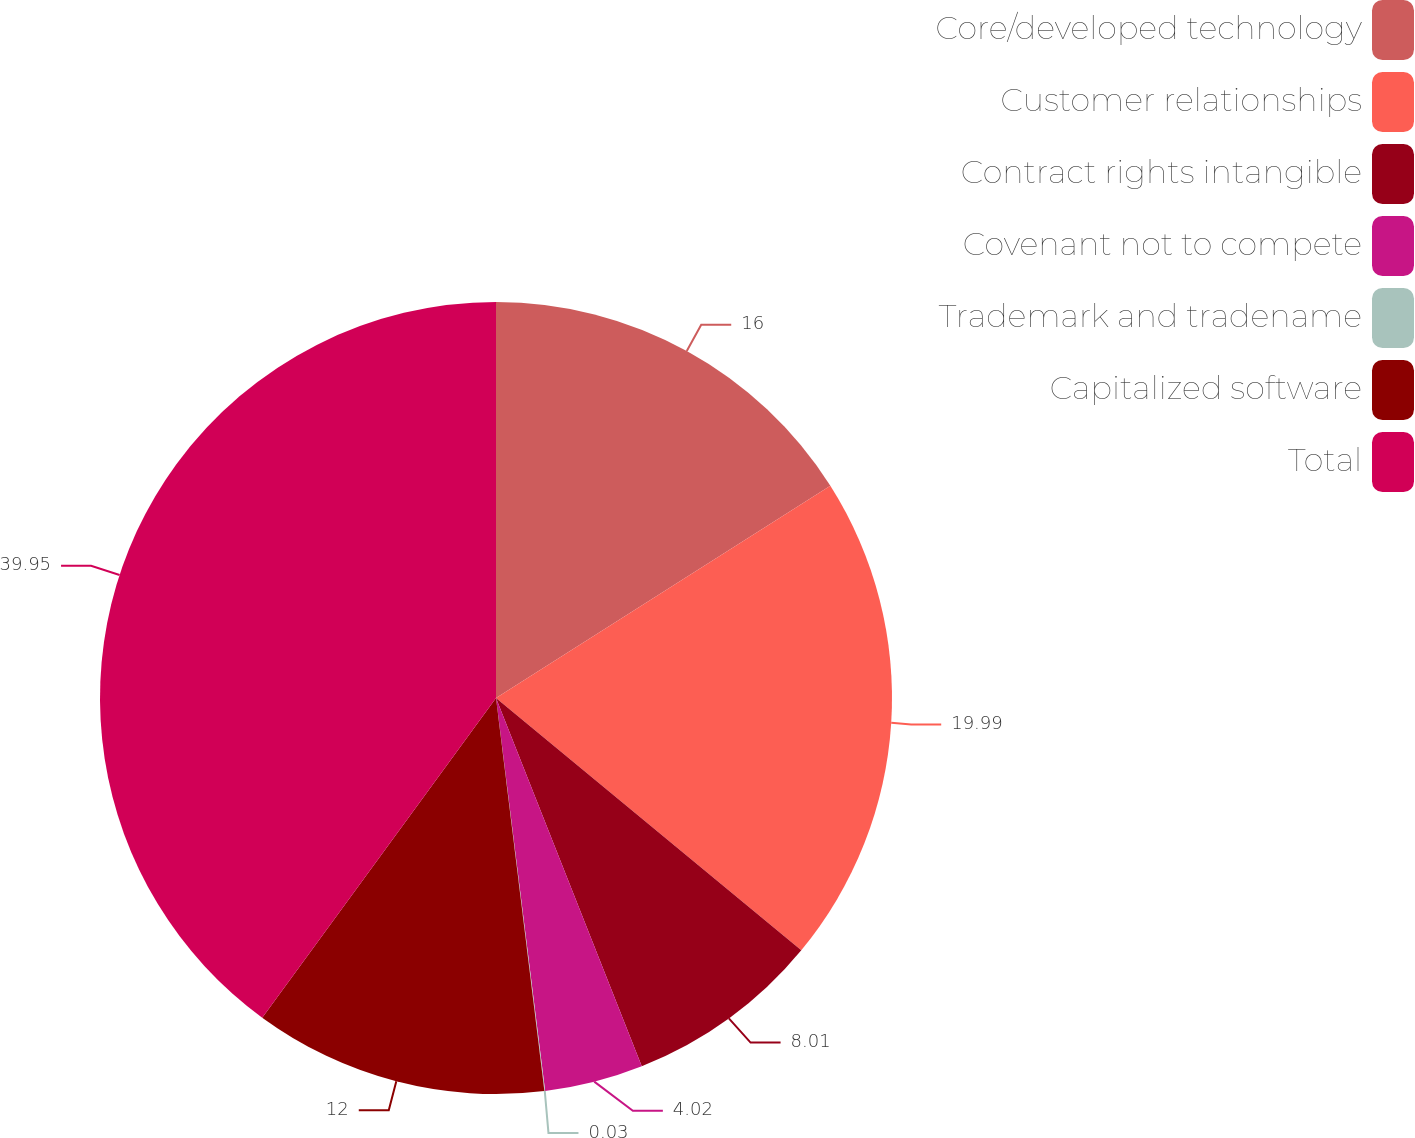Convert chart. <chart><loc_0><loc_0><loc_500><loc_500><pie_chart><fcel>Core/developed technology<fcel>Customer relationships<fcel>Contract rights intangible<fcel>Covenant not to compete<fcel>Trademark and tradename<fcel>Capitalized software<fcel>Total<nl><fcel>16.0%<fcel>19.99%<fcel>8.01%<fcel>4.02%<fcel>0.03%<fcel>12.0%<fcel>39.95%<nl></chart> 